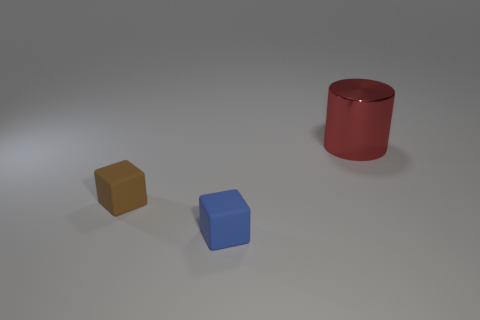What number of other objects are the same size as the red cylinder?
Make the answer very short. 0. There is a tiny block on the left side of the matte object that is right of the small matte cube behind the tiny blue cube; what is it made of?
Your answer should be compact. Rubber. Do the brown object and the cube that is on the right side of the brown matte thing have the same size?
Make the answer very short. Yes. There is a object that is both left of the cylinder and on the right side of the tiny brown matte thing; what is its size?
Offer a terse response. Small. Are there any small rubber blocks of the same color as the cylinder?
Your answer should be very brief. No. What is the color of the block that is on the left side of the tiny object in front of the brown matte block?
Your response must be concise. Brown. Are there fewer brown objects that are in front of the small brown thing than matte things that are behind the big thing?
Offer a very short reply. No. Is the blue thing the same size as the cylinder?
Offer a very short reply. No. The thing that is both in front of the big red metal thing and behind the tiny blue rubber object has what shape?
Give a very brief answer. Cube. How many large brown spheres have the same material as the small brown thing?
Offer a very short reply. 0. 